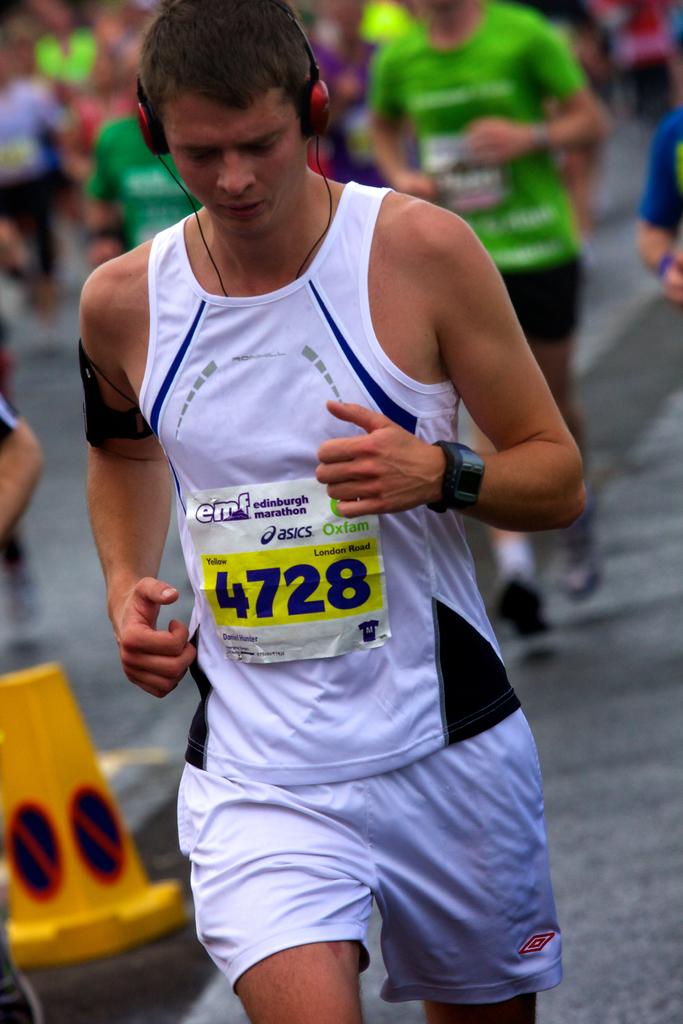What is the runner's number?
Make the answer very short. 4728. What brand is above the number?
Offer a terse response. Asics. 